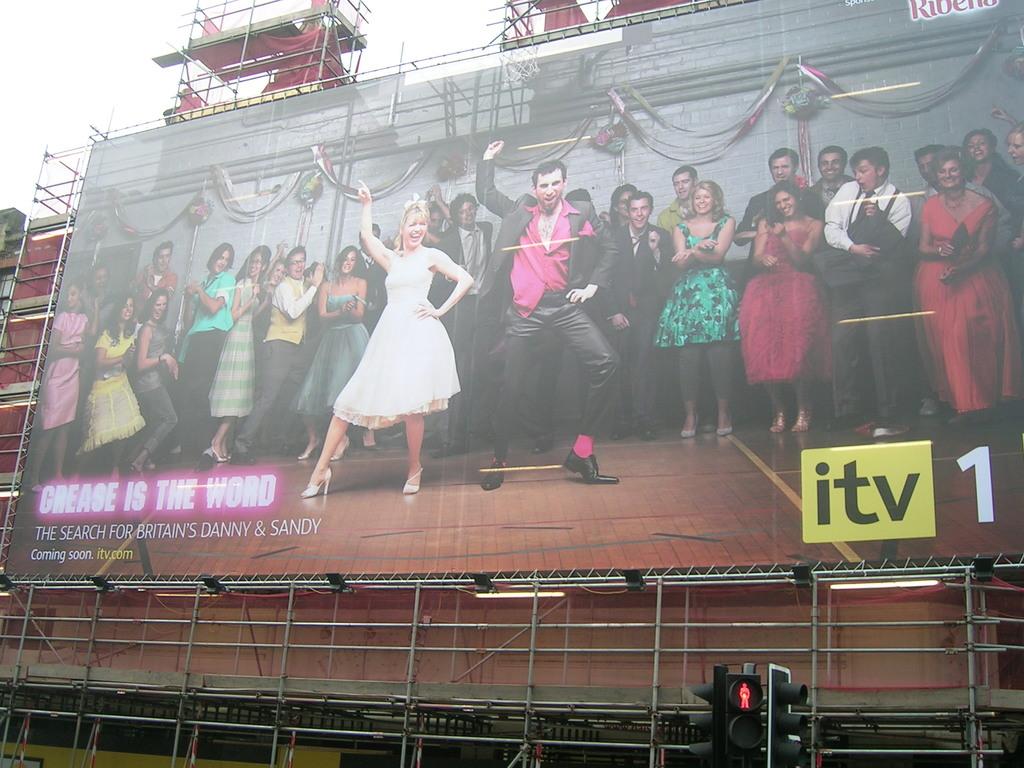What channel is grease going to be on?
Your answer should be very brief. Itv. What is the search of?
Your answer should be very brief. Britain's danny & sandy. 